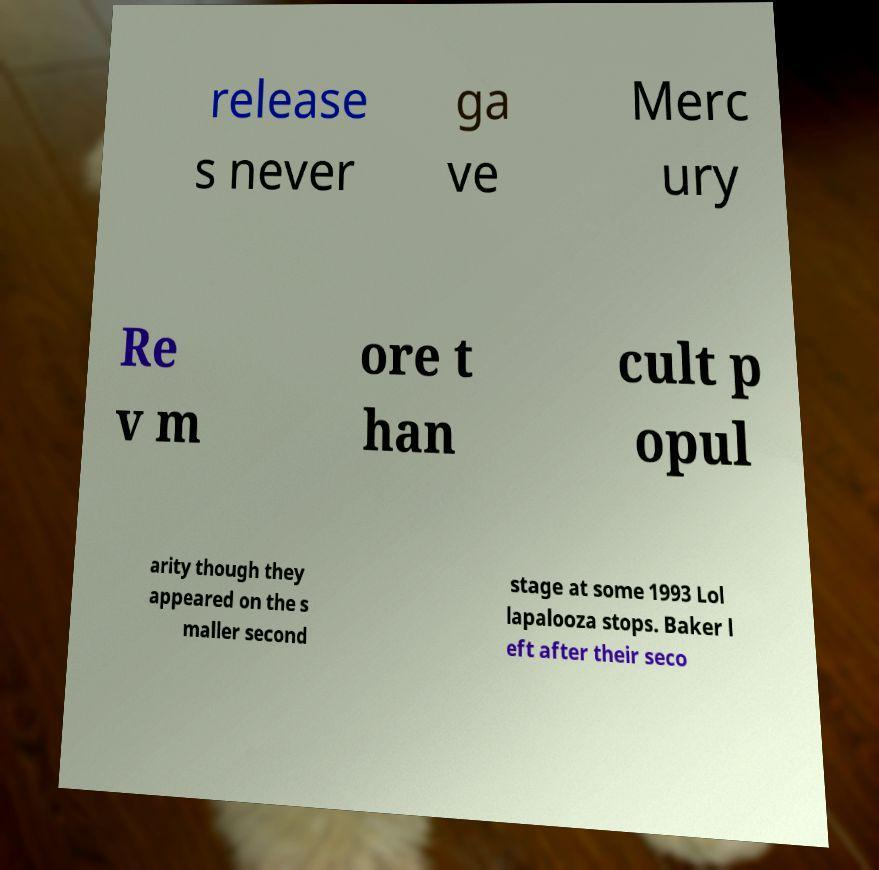There's text embedded in this image that I need extracted. Can you transcribe it verbatim? release s never ga ve Merc ury Re v m ore t han cult p opul arity though they appeared on the s maller second stage at some 1993 Lol lapalooza stops. Baker l eft after their seco 